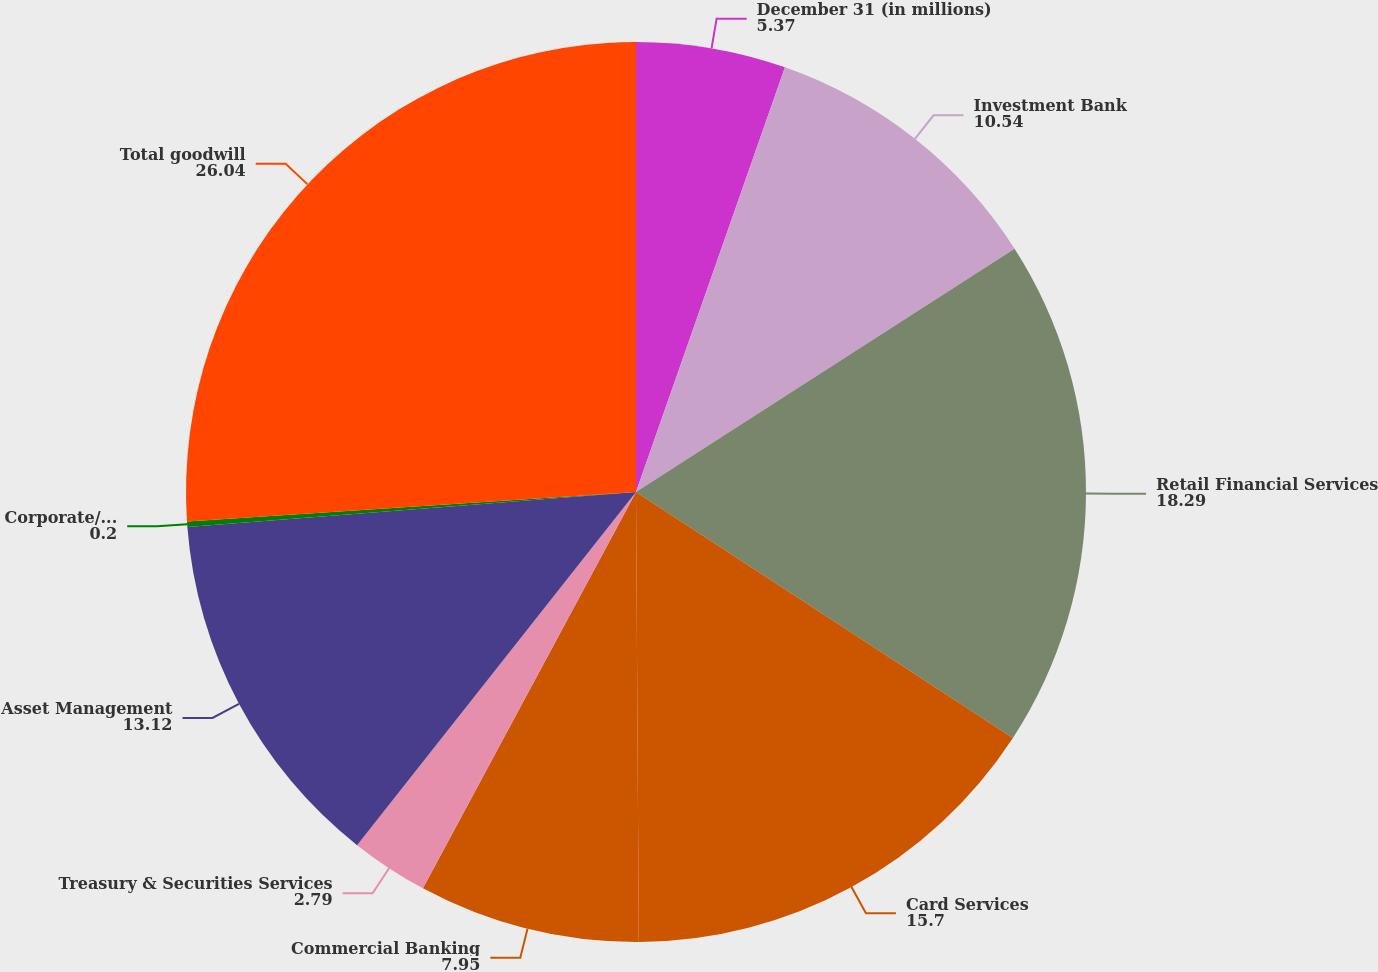Convert chart to OTSL. <chart><loc_0><loc_0><loc_500><loc_500><pie_chart><fcel>December 31 (in millions)<fcel>Investment Bank<fcel>Retail Financial Services<fcel>Card Services<fcel>Commercial Banking<fcel>Treasury & Securities Services<fcel>Asset Management<fcel>Corporate/Private Equity<fcel>Total goodwill<nl><fcel>5.37%<fcel>10.54%<fcel>18.29%<fcel>15.7%<fcel>7.95%<fcel>2.79%<fcel>13.12%<fcel>0.2%<fcel>26.04%<nl></chart> 